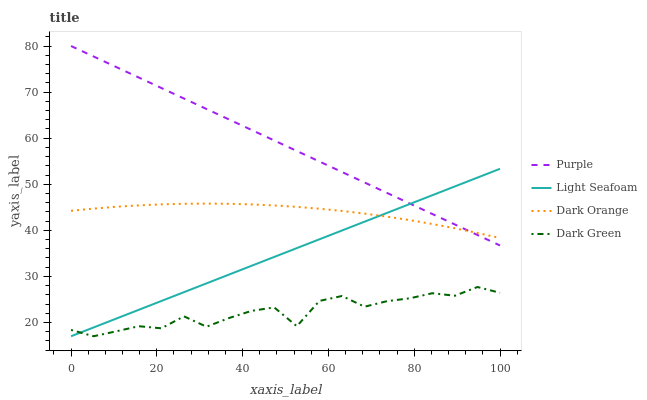Does Dark Green have the minimum area under the curve?
Answer yes or no. Yes. Does Purple have the maximum area under the curve?
Answer yes or no. Yes. Does Dark Orange have the minimum area under the curve?
Answer yes or no. No. Does Dark Orange have the maximum area under the curve?
Answer yes or no. No. Is Light Seafoam the smoothest?
Answer yes or no. Yes. Is Dark Green the roughest?
Answer yes or no. Yes. Is Dark Orange the smoothest?
Answer yes or no. No. Is Dark Orange the roughest?
Answer yes or no. No. Does Light Seafoam have the lowest value?
Answer yes or no. Yes. Does Dark Orange have the lowest value?
Answer yes or no. No. Does Purple have the highest value?
Answer yes or no. Yes. Does Dark Orange have the highest value?
Answer yes or no. No. Is Dark Green less than Dark Orange?
Answer yes or no. Yes. Is Dark Orange greater than Dark Green?
Answer yes or no. Yes. Does Light Seafoam intersect Purple?
Answer yes or no. Yes. Is Light Seafoam less than Purple?
Answer yes or no. No. Is Light Seafoam greater than Purple?
Answer yes or no. No. Does Dark Green intersect Dark Orange?
Answer yes or no. No. 